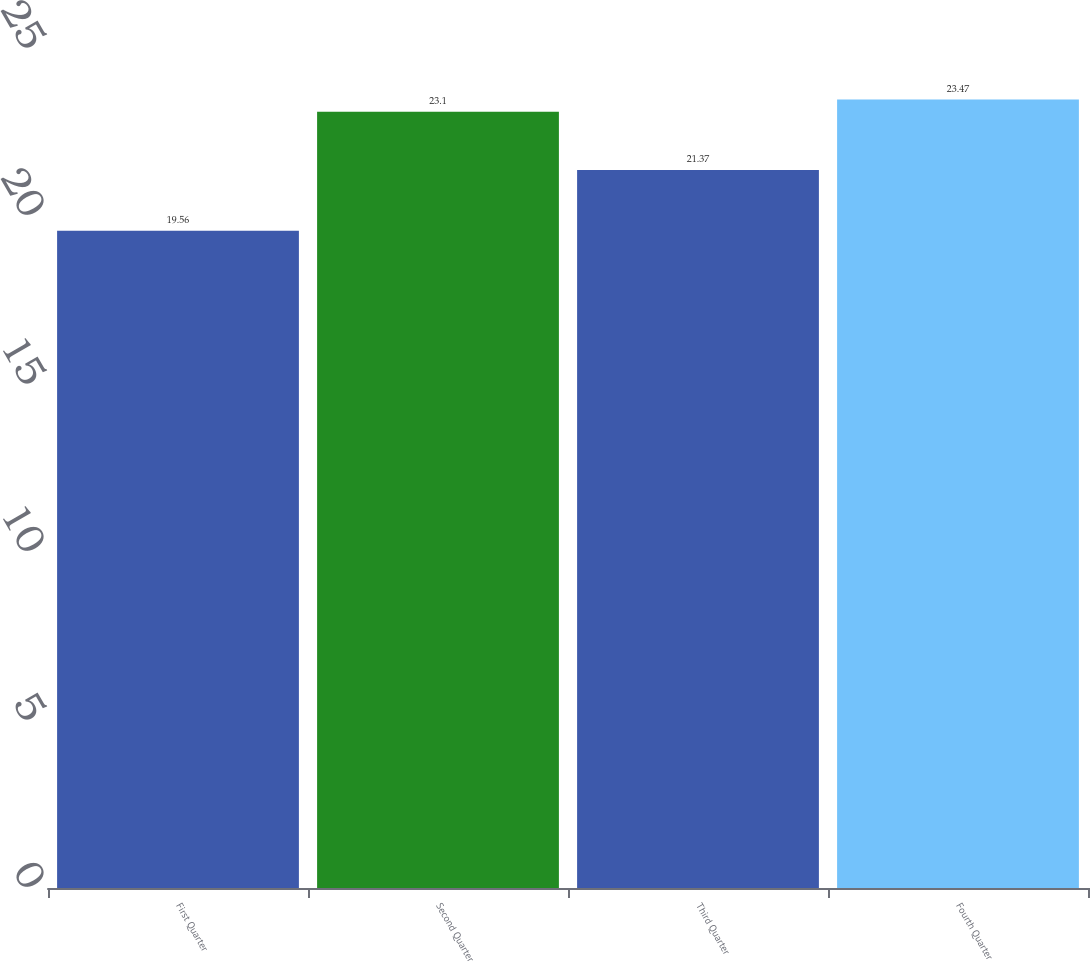Convert chart to OTSL. <chart><loc_0><loc_0><loc_500><loc_500><bar_chart><fcel>First Quarter<fcel>Second Quarter<fcel>Third Quarter<fcel>Fourth Quarter<nl><fcel>19.56<fcel>23.1<fcel>21.37<fcel>23.47<nl></chart> 